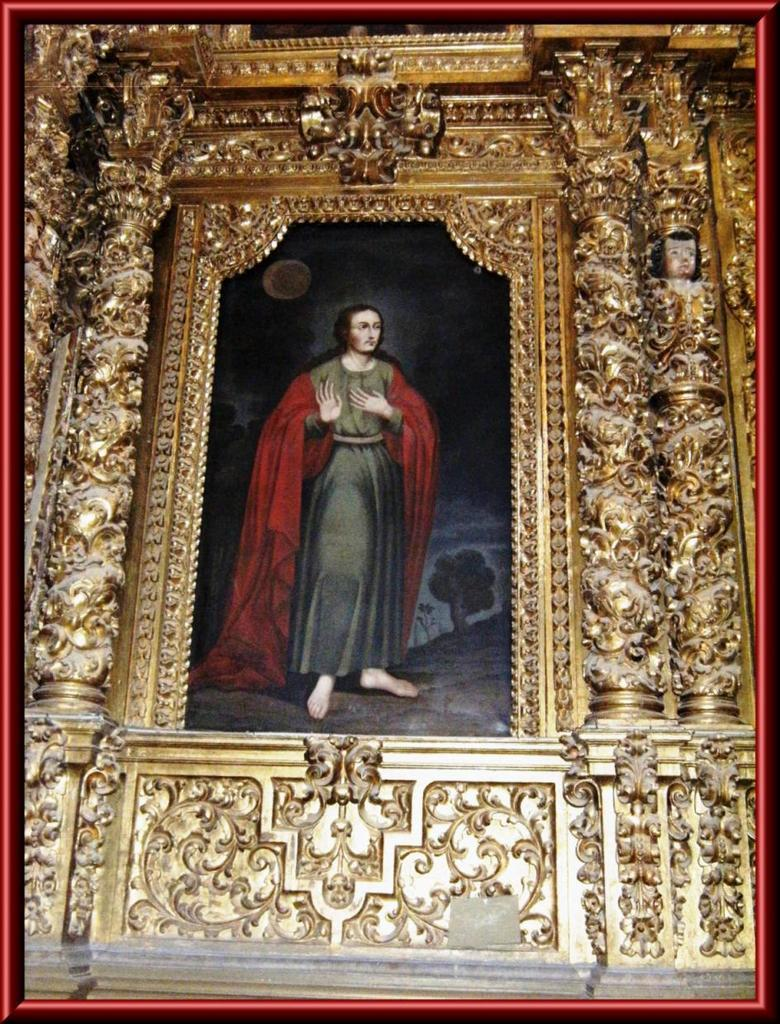What is the main subject of the image? The main subject of the image is a frame. What is inside the frame? The frame contains a portrait painting of a person. Are there any additional features on the frame? Yes, there are design carvings on the frame. How does the health of the person in the portrait painting appear to be? The image does not provide any information about the health of the person in the portrait painting. 